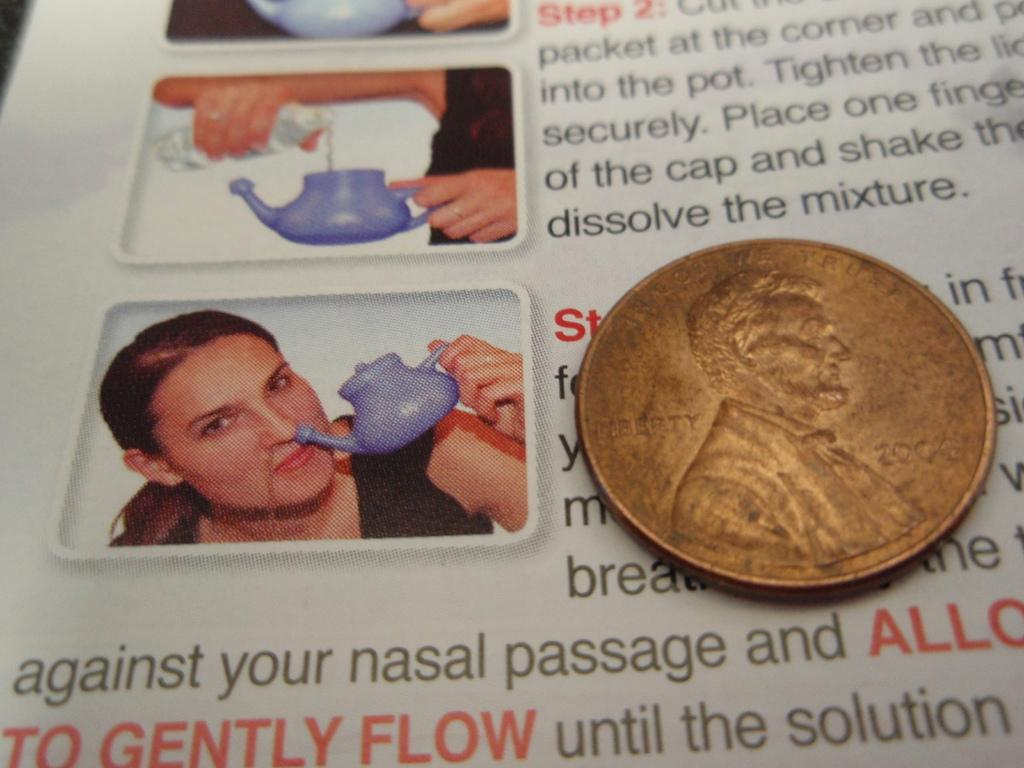What object is visible in the image? There is a coin in the image. Where is the coin placed? The coin is placed on a paper. What can be found on the paper? The paper contains text and images. How many houses are visible in the image? There are no houses visible in the image; it only contains a coin placed on a paper with text and images. Are there any dinosaurs present in the image? There are no dinosaurs present in the image; it only contains a coin placed on a paper with text and images. 